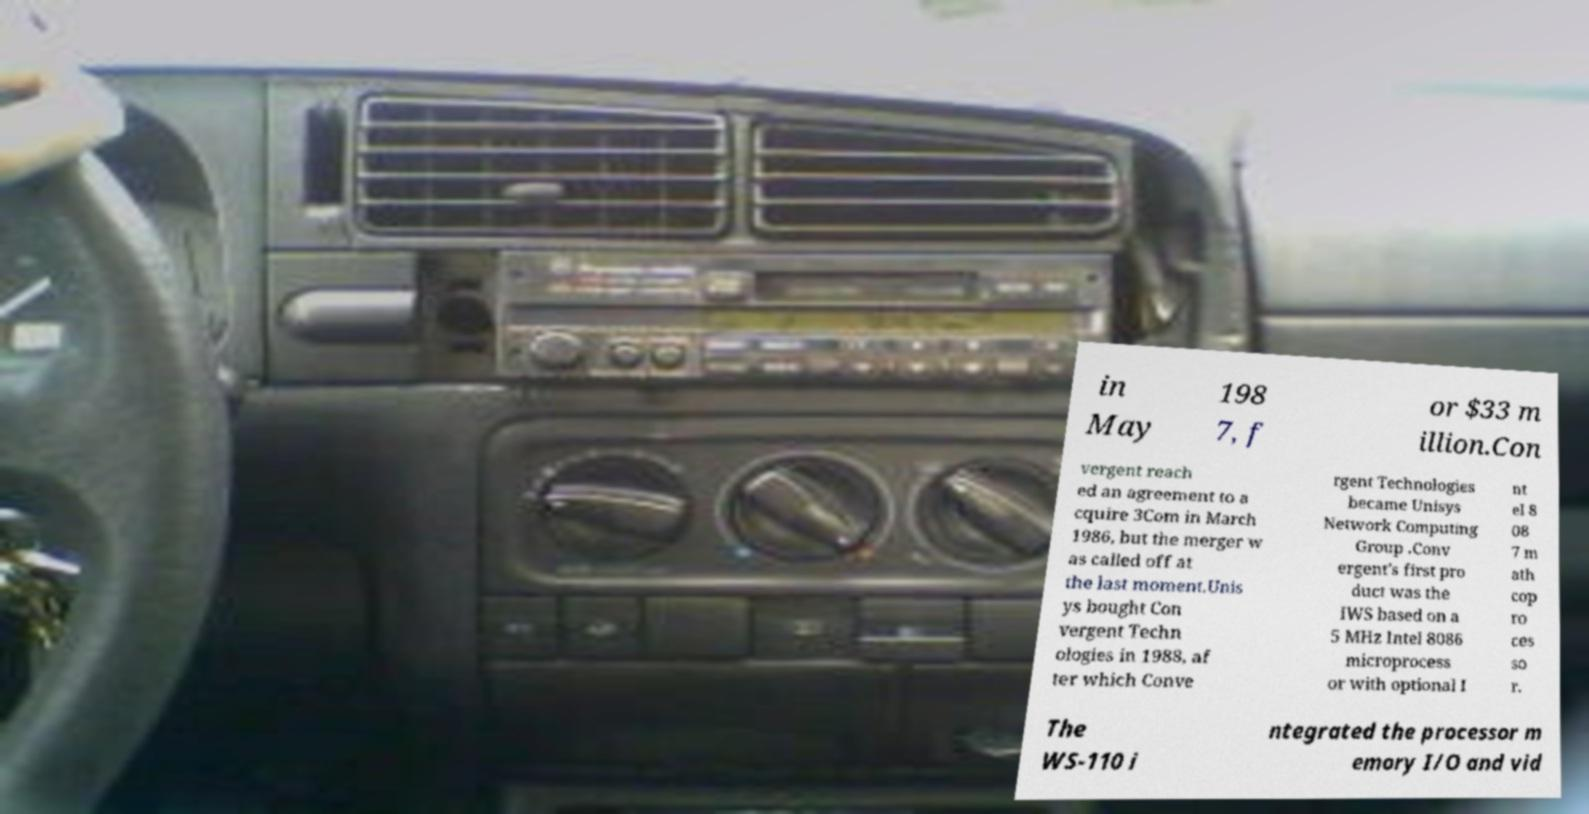Please read and relay the text visible in this image. What does it say? in May 198 7, f or $33 m illion.Con vergent reach ed an agreement to a cquire 3Com in March 1986, but the merger w as called off at the last moment.Unis ys bought Con vergent Techn ologies in 1988, af ter which Conve rgent Technologies became Unisys Network Computing Group .Conv ergent's first pro duct was the IWS based on a 5 MHz Intel 8086 microprocess or with optional I nt el 8 08 7 m ath cop ro ces so r. The WS-110 i ntegrated the processor m emory I/O and vid 